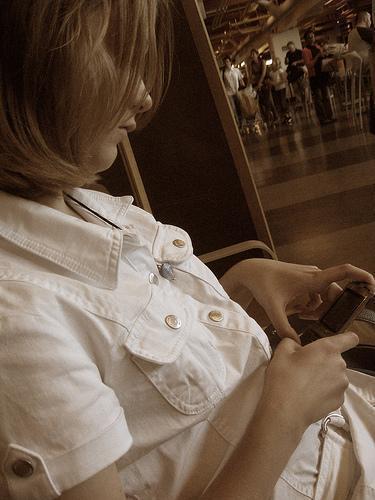How many phones?
Give a very brief answer. 1. 